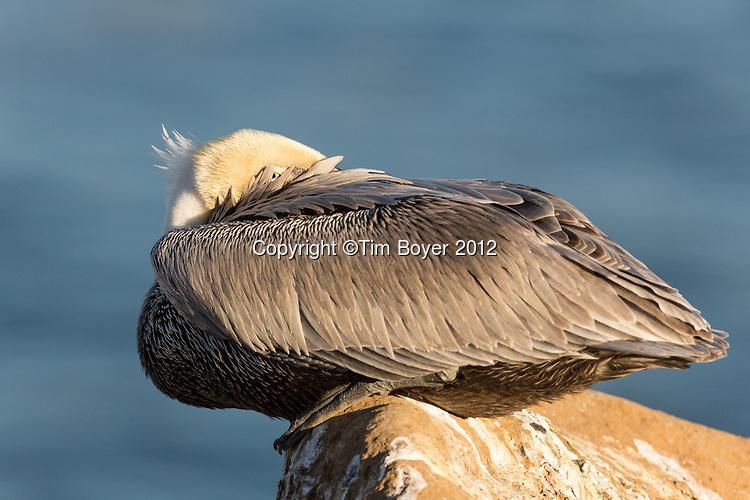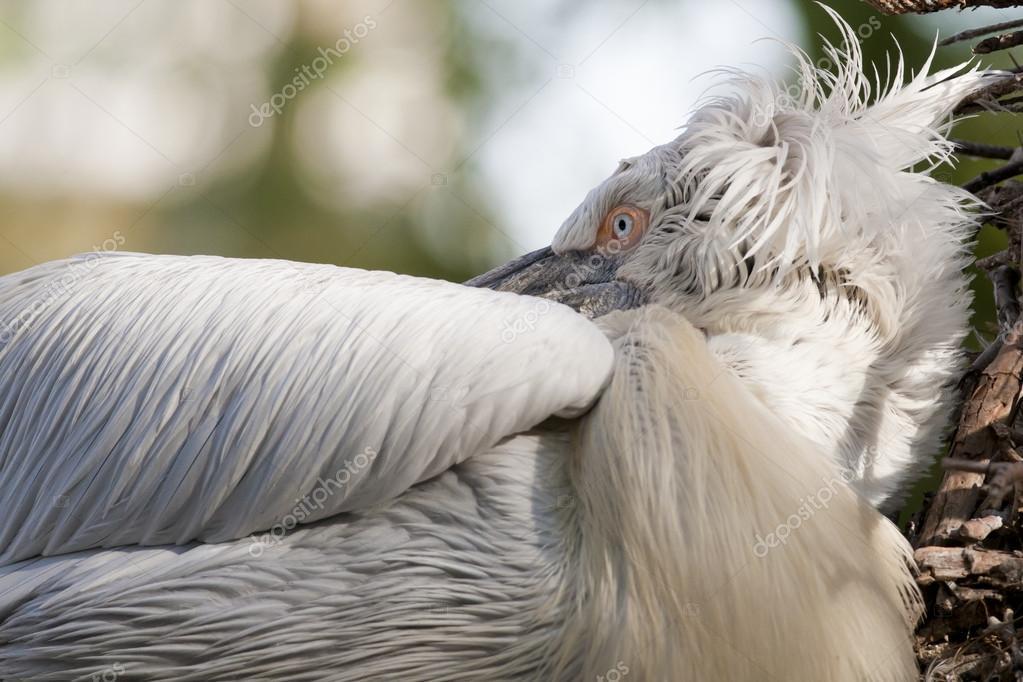The first image is the image on the left, the second image is the image on the right. Examine the images to the left and right. Is the description "There's no more than two birds." accurate? Answer yes or no. Yes. The first image is the image on the left, the second image is the image on the right. Assess this claim about the two images: "One image shows a single white bird tucked into an egg shape, and the other shows a group of black-and-white birds with necks tucked backward.". Correct or not? Answer yes or no. No. 